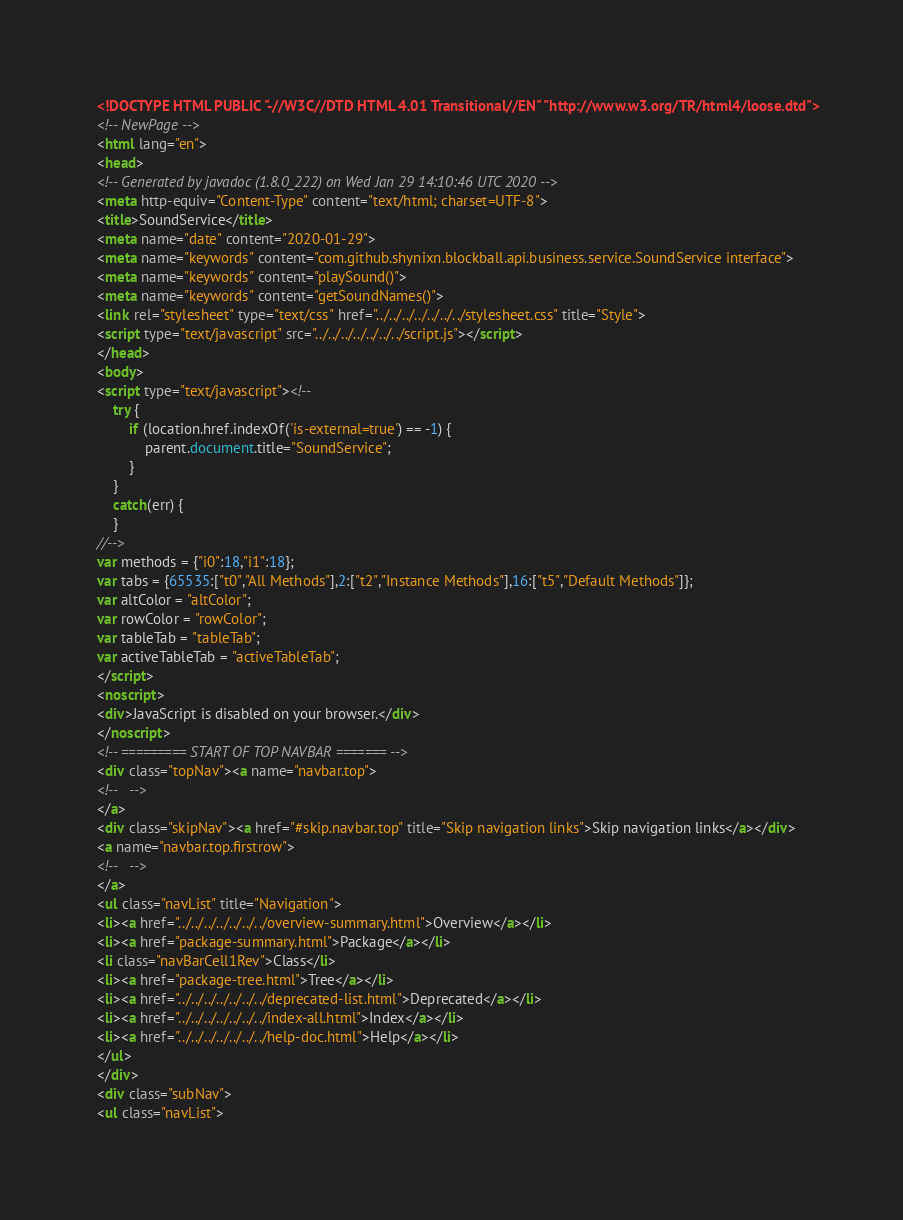Convert code to text. <code><loc_0><loc_0><loc_500><loc_500><_HTML_><!DOCTYPE HTML PUBLIC "-//W3C//DTD HTML 4.01 Transitional//EN" "http://www.w3.org/TR/html4/loose.dtd">
<!-- NewPage -->
<html lang="en">
<head>
<!-- Generated by javadoc (1.8.0_222) on Wed Jan 29 14:10:46 UTC 2020 -->
<meta http-equiv="Content-Type" content="text/html; charset=UTF-8">
<title>SoundService</title>
<meta name="date" content="2020-01-29">
<meta name="keywords" content="com.github.shynixn.blockball.api.business.service.SoundService interface">
<meta name="keywords" content="playSound()">
<meta name="keywords" content="getSoundNames()">
<link rel="stylesheet" type="text/css" href="../../../../../../../stylesheet.css" title="Style">
<script type="text/javascript" src="../../../../../../../script.js"></script>
</head>
<body>
<script type="text/javascript"><!--
    try {
        if (location.href.indexOf('is-external=true') == -1) {
            parent.document.title="SoundService";
        }
    }
    catch(err) {
    }
//-->
var methods = {"i0":18,"i1":18};
var tabs = {65535:["t0","All Methods"],2:["t2","Instance Methods"],16:["t5","Default Methods"]};
var altColor = "altColor";
var rowColor = "rowColor";
var tableTab = "tableTab";
var activeTableTab = "activeTableTab";
</script>
<noscript>
<div>JavaScript is disabled on your browser.</div>
</noscript>
<!-- ========= START OF TOP NAVBAR ======= -->
<div class="topNav"><a name="navbar.top">
<!--   -->
</a>
<div class="skipNav"><a href="#skip.navbar.top" title="Skip navigation links">Skip navigation links</a></div>
<a name="navbar.top.firstrow">
<!--   -->
</a>
<ul class="navList" title="Navigation">
<li><a href="../../../../../../../overview-summary.html">Overview</a></li>
<li><a href="package-summary.html">Package</a></li>
<li class="navBarCell1Rev">Class</li>
<li><a href="package-tree.html">Tree</a></li>
<li><a href="../../../../../../../deprecated-list.html">Deprecated</a></li>
<li><a href="../../../../../../../index-all.html">Index</a></li>
<li><a href="../../../../../../../help-doc.html">Help</a></li>
</ul>
</div>
<div class="subNav">
<ul class="navList"></code> 